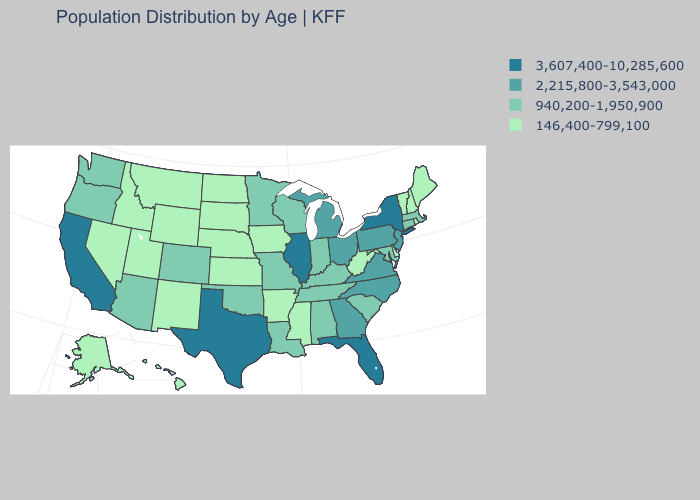Which states have the highest value in the USA?
Give a very brief answer. California, Florida, Illinois, New York, Texas. What is the value of California?
Be succinct. 3,607,400-10,285,600. Which states have the lowest value in the USA?
Give a very brief answer. Alaska, Arkansas, Delaware, Hawaii, Idaho, Iowa, Kansas, Maine, Mississippi, Montana, Nebraska, Nevada, New Hampshire, New Mexico, North Dakota, Rhode Island, South Dakota, Utah, Vermont, West Virginia, Wyoming. What is the value of Georgia?
Give a very brief answer. 2,215,800-3,543,000. What is the value of Delaware?
Write a very short answer. 146,400-799,100. What is the value of South Carolina?
Short answer required. 940,200-1,950,900. What is the value of Wyoming?
Keep it brief. 146,400-799,100. Is the legend a continuous bar?
Answer briefly. No. Among the states that border Rhode Island , which have the lowest value?
Keep it brief. Connecticut, Massachusetts. Which states have the highest value in the USA?
Quick response, please. California, Florida, Illinois, New York, Texas. What is the value of Wyoming?
Keep it brief. 146,400-799,100. Does Wyoming have the lowest value in the West?
Short answer required. Yes. What is the highest value in the South ?
Answer briefly. 3,607,400-10,285,600. What is the value of Minnesota?
Keep it brief. 940,200-1,950,900. Name the states that have a value in the range 2,215,800-3,543,000?
Answer briefly. Georgia, Michigan, New Jersey, North Carolina, Ohio, Pennsylvania, Virginia. 